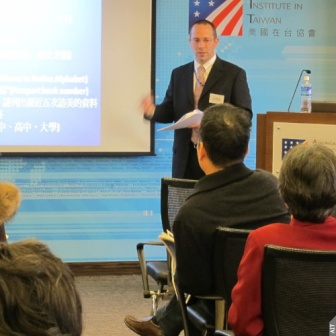Describe the following image. In the image, a man is delivering a presentation in a conference or lecture hall. He stands in front of a projected screen displaying content in both English and Chinese. The presentation appears to be about the American Institute in Taiwan, as indicated by the visible text on the screen: 'American Institute in Taiwan' and '台灣美國學會.' The presenter is holding a paper, likely his notes or a script, and is actively engaged with the audience, who are seated attentively in rows of chairs facing him. The scene captures a formal and professional atmosphere suitable for academic or professional presentations. The blue screen contrasts with the otherwise neutral tones in the room, drawing attention to the visual aid. The number of audience members is indeterminate, but their body language suggests they are focused on the speaker, indicating an ongoing speech or lecture. 